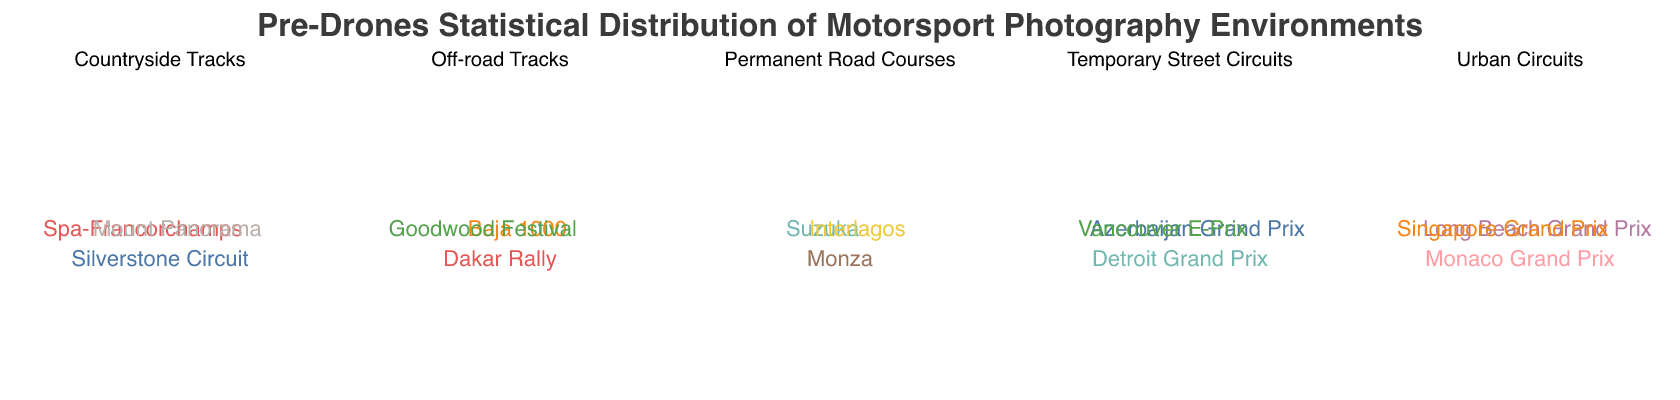What's the title of the figure? The title is usually displayed prominently at the top of the figure.
Answer: Pre-Drones Statistical Distribution of Motorsport Photography Environments Which category had the highest number of settings in the "Pre-Drones" era? By summing up the settings in each category: Urban Circuits (45+25+35)=105, Countryside Tracks (50+55+40)=145, Permanent Road Courses (60+45+50)=155, Temporary Street Circuits (30+20+25)=75, and Off-road Tracks (30+35+25)=90. Permanent Road Courses have the highest sum.
Answer: Permanent Road Courses How does the setting count for "Monaco Grand Prix" differ between the Pre-Drones and Post-Drones era? Look at the data for "Monaco Grand Prix": Pre-Drones (45) and Post-Drones (30). Subtract Pre-Drones from Post-Drones: 30 - 45 = -15.
Answer: -15 For "Permanent Road Courses," which setting saw the smallest difference between Pre-Drones and Post-Drones? Compare differences for Monza (70-60), Suzuka (50-45), and Interlagos (55-50). Calculate differences: Monza (10), Suzuka (5), Interlagos (5). Suzuka and Interlagos both have the smallest difference of 5.
Answer: Suzuka, Interlagos Which setting in "Urban Circuits" increased the most in the number of shoots from the Pre-Drones to Post-Drones era? Compare the Pre-Drones and Post-Drones counts for each setting: Monaco Grand Prix (-15), Long Beach Grand Prix (15), Singapore Grand Prix (15). Both Long Beach and Singapore Grand Prix increased most by 15 each.
Answer: Long Beach Grand Prix, Singapore Grand Prix What is the combined total of Pre-Drones shoots for all "Off-road Tracks" settings? Sum the Pre-Drones values for Baja 1000 (30), Dakar Rally (35), and Goodwood Festival (25). Add them: 30 + 35 + 25 = 90.
Answer: 90 In "Temporary Street Circuits," which setting had the lowest Pre-Drones shoot count? Compare Pre-Drones values: Detroit Grand Prix (30), Azerbaijan Grand Prix (20), Vancouver E-Prix (25). The lowest value is for Azerbaijan Grand Prix (20).
Answer: Azerbaijan Grand Prix Which category had a decrease in total shoots in the Post-Drones era compared to the Pre-Drones era? By summing total values of each category in both eras: Urban Circuits (Pre: 105, Post: 30+40+50=120), Countryside Tracks (Pre: 145, Post: 60+45+35=140), Permanent Road Courses (Pre: 155, Post: 70+50+55=175), Temporary Street Circuits (Pre: 75, Post: 40+35+45=120), Off-road Tracks (Pre: 90, Post: 50+60+40=150). Only Countryside Tracks decreased from 145 to 140.
Answer: Countryside Tracks 